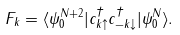Convert formula to latex. <formula><loc_0><loc_0><loc_500><loc_500>F _ { k } = \langle \psi ^ { N + 2 } _ { 0 } | c ^ { \dagger } _ { { k } \uparrow } c ^ { \dagger } _ { - { k } \downarrow } | \psi ^ { N } _ { 0 } \rangle .</formula> 